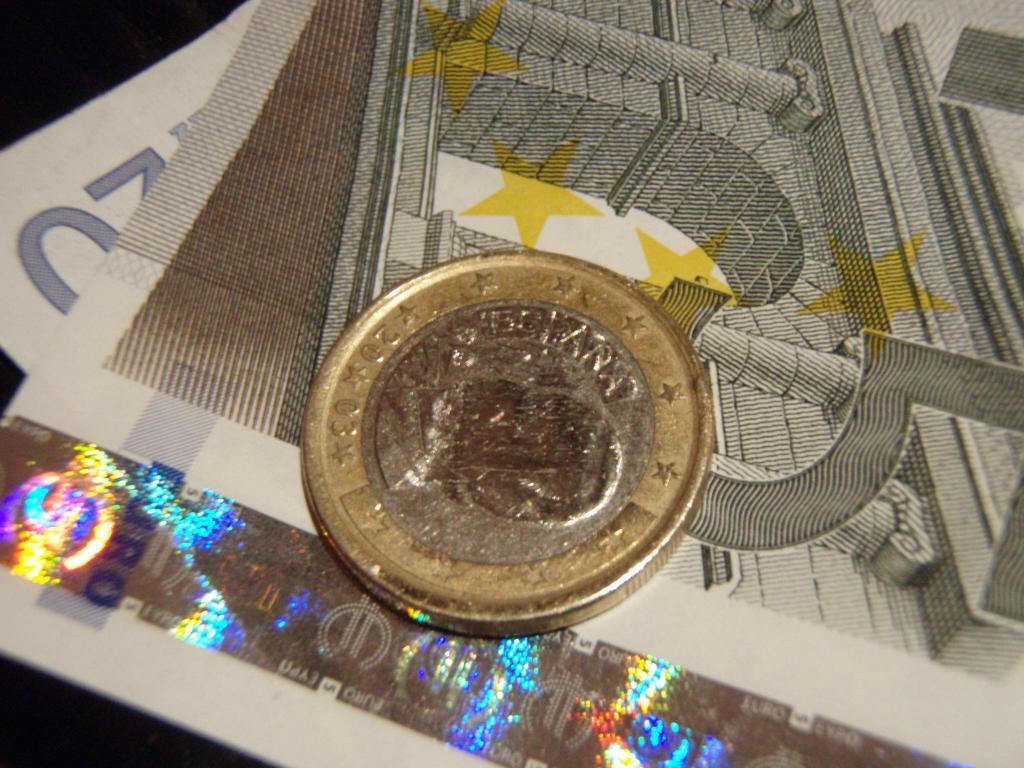In one or two sentences, can you explain what this image depicts? In the picture we can see some currency notes and a coin on it which is gold and some part silver in color with a symbol on it. 